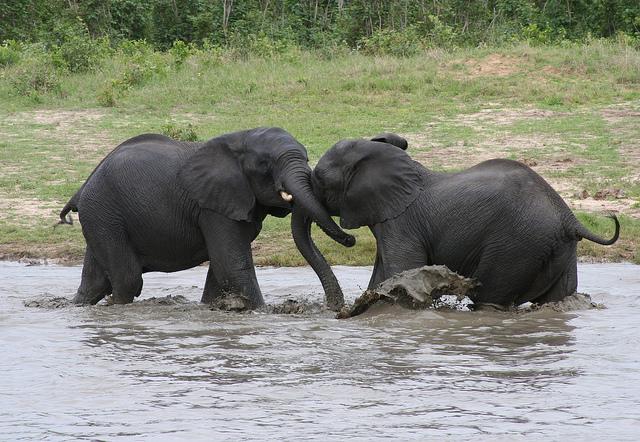What are the white things on the elephant's face?
Quick response, please. Tusks. How many elephants are in the picture?
Write a very short answer. 2. Are the elephants in the water?
Answer briefly. Yes. What are the elephants doing?
Quick response, please. Playing. 